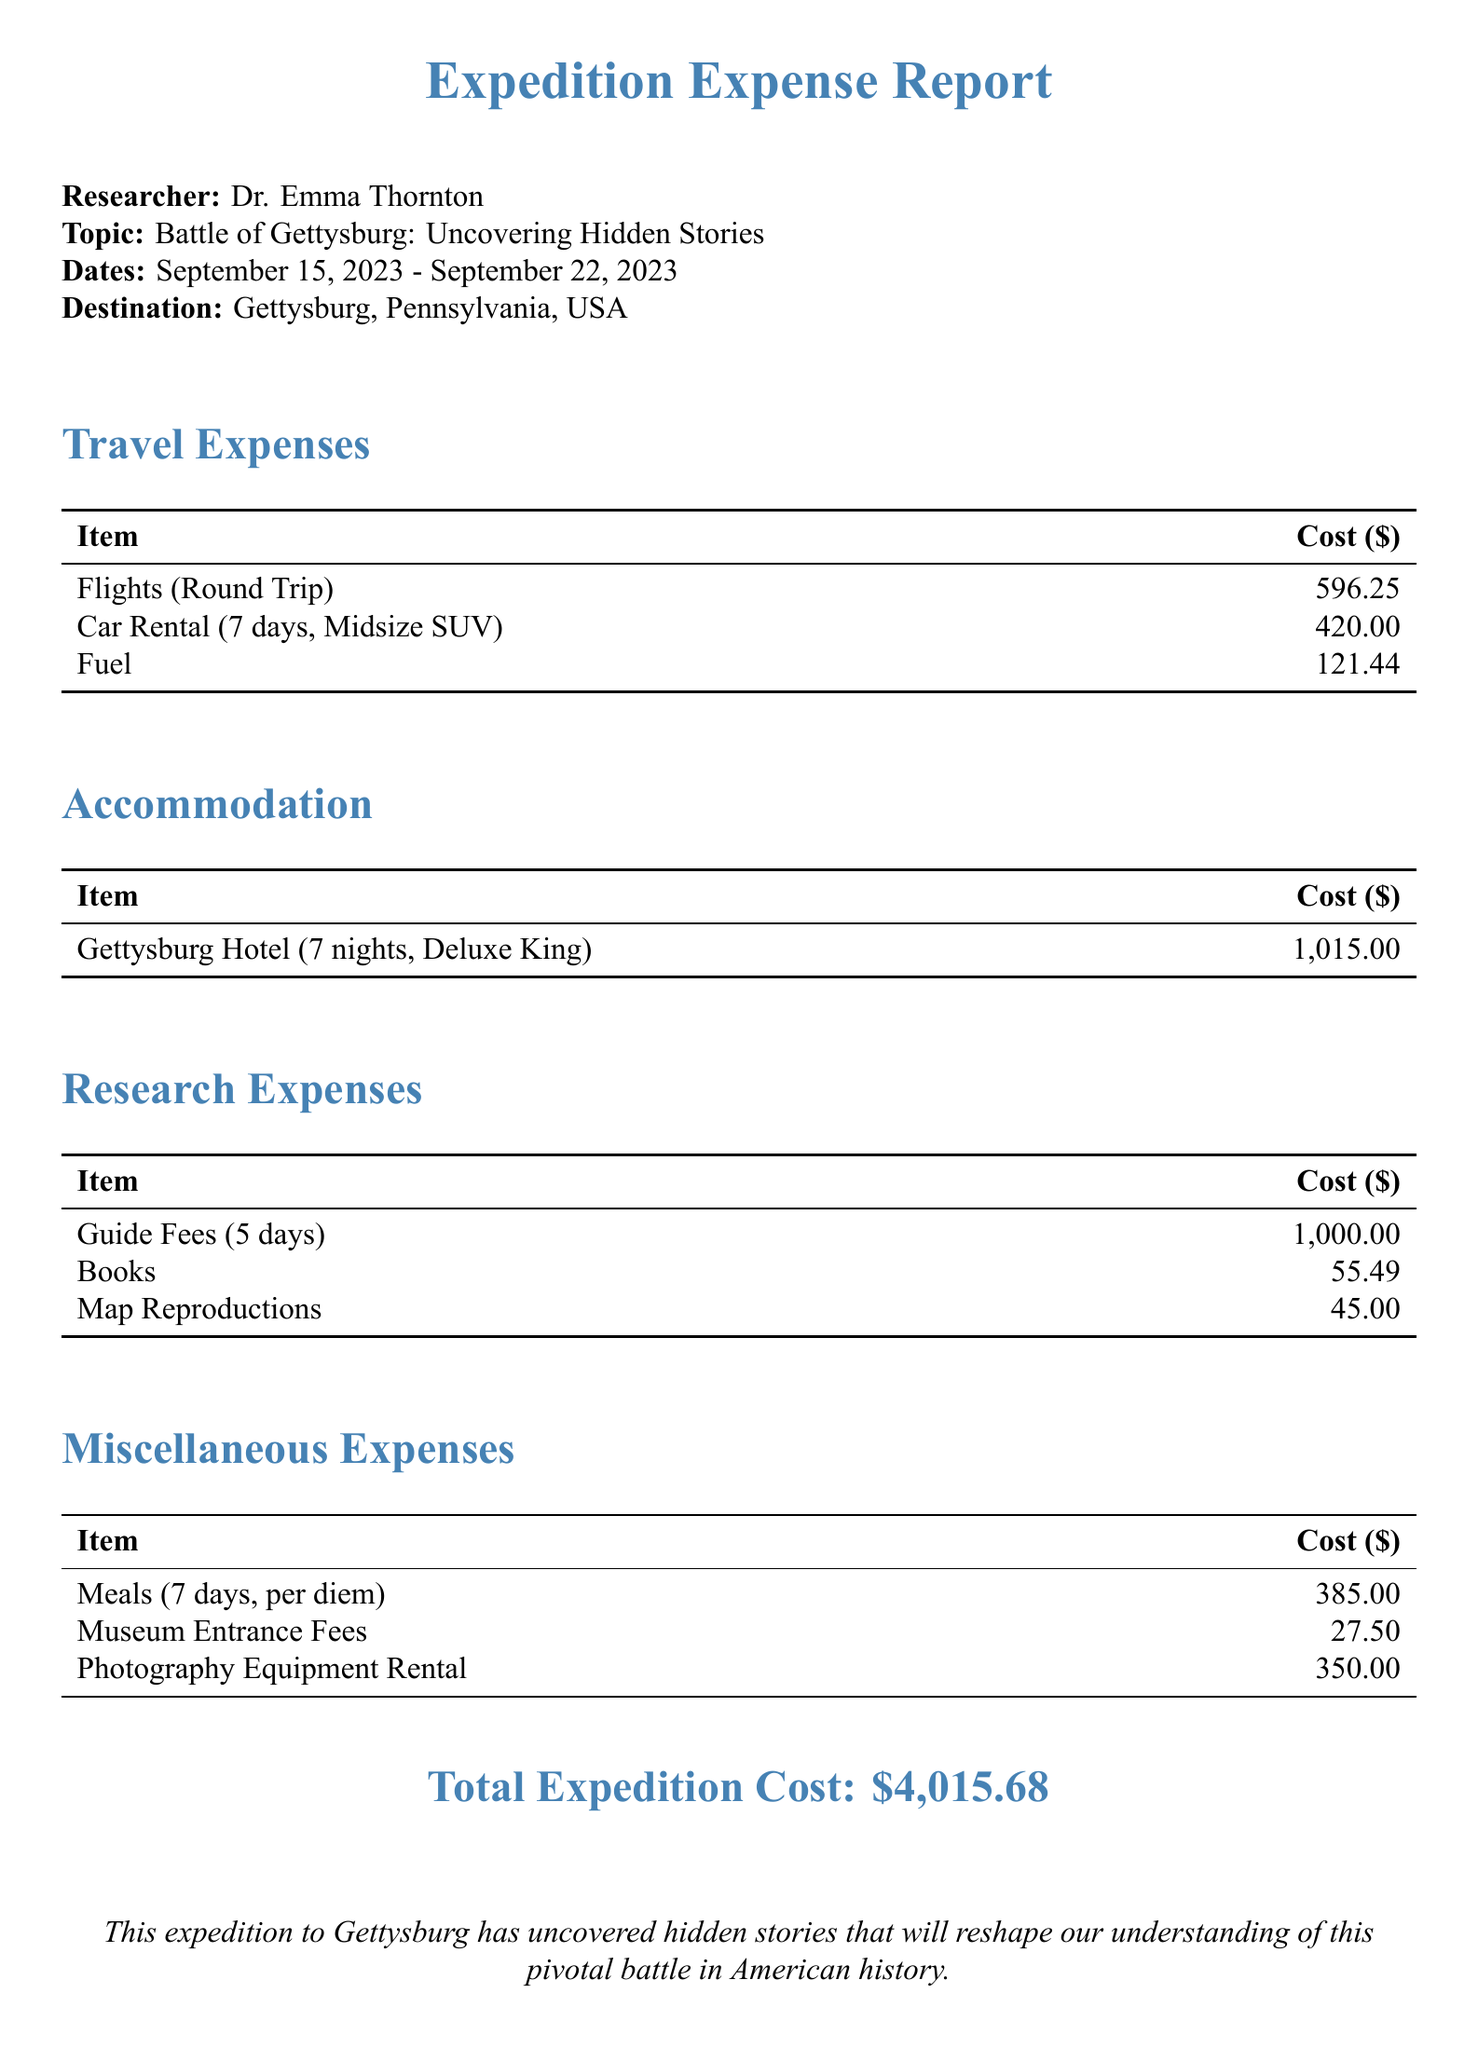What is the researcher’s name? The document states the researcher’s name as Dr. Emma Thornton.
Answer: Dr. Emma Thornton What was the destination of the research trip? The document indicates that the destination of the research trip was Gettysburg, Pennsylvania, USA.
Answer: Gettysburg, Pennsylvania, USA What was the total cost of the accommodation? The total accommodation cost is explicitly mentioned in the document as $1,015.00.
Answer: $1,015.00 How many nights did the researcher stay at the hotel? The document shows that the researcher stayed for 7 nights at the hotel.
Answer: 7 nights What was the total cost of meals? The document lists the total cost for meals as $385.00 for the duration of the trip.
Answer: $385.00 What is the daily rate for the guide? The document provides the daily rate for the guide as $200.00.
Answer: $200.00 What is the total cost of flights? The total cost for flights is calculated in the document as $596.25 for round trip.
Answer: $596.25 What is the total expedition cost? The document clearly summarizes the total expedition cost as $4,015.68.
Answer: $4,015.68 How many days did the guide assist the researcher? The document specifies that the guide assisted the researcher for 5 days.
Answer: 5 days 